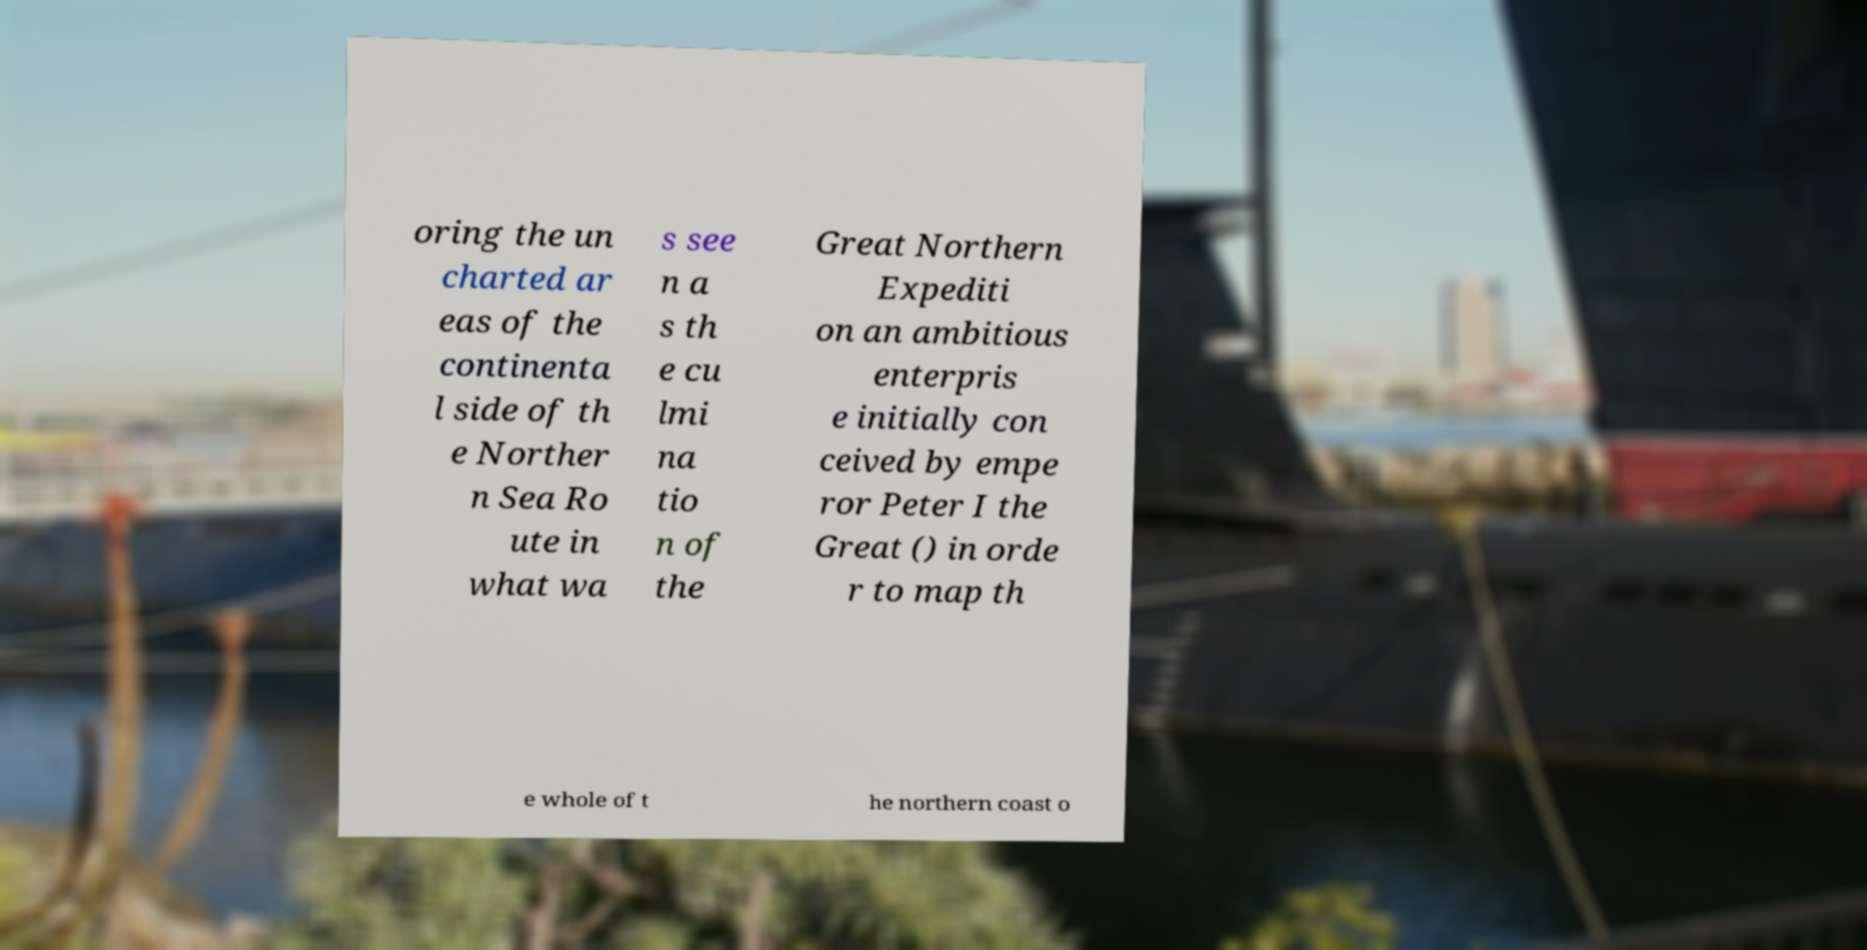I need the written content from this picture converted into text. Can you do that? oring the un charted ar eas of the continenta l side of th e Norther n Sea Ro ute in what wa s see n a s th e cu lmi na tio n of the Great Northern Expediti on an ambitious enterpris e initially con ceived by empe ror Peter I the Great () in orde r to map th e whole of t he northern coast o 